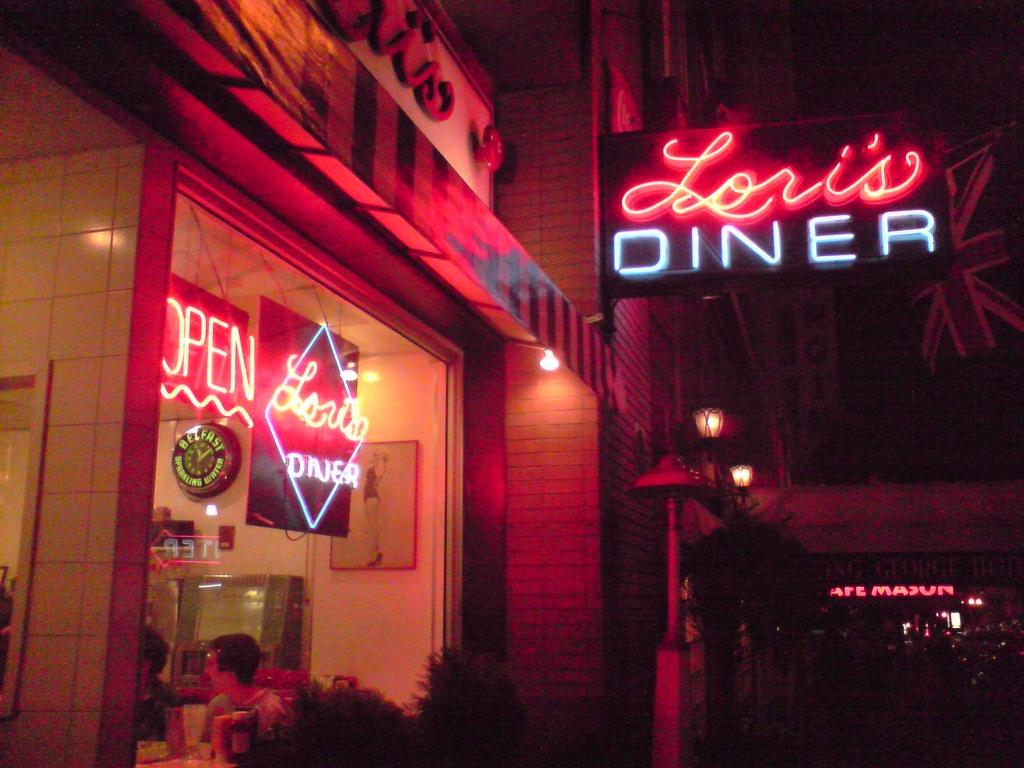<image>
Provide a brief description of the given image. Diner with people indoors and a large sign outdoors saying Lori's Diner. 